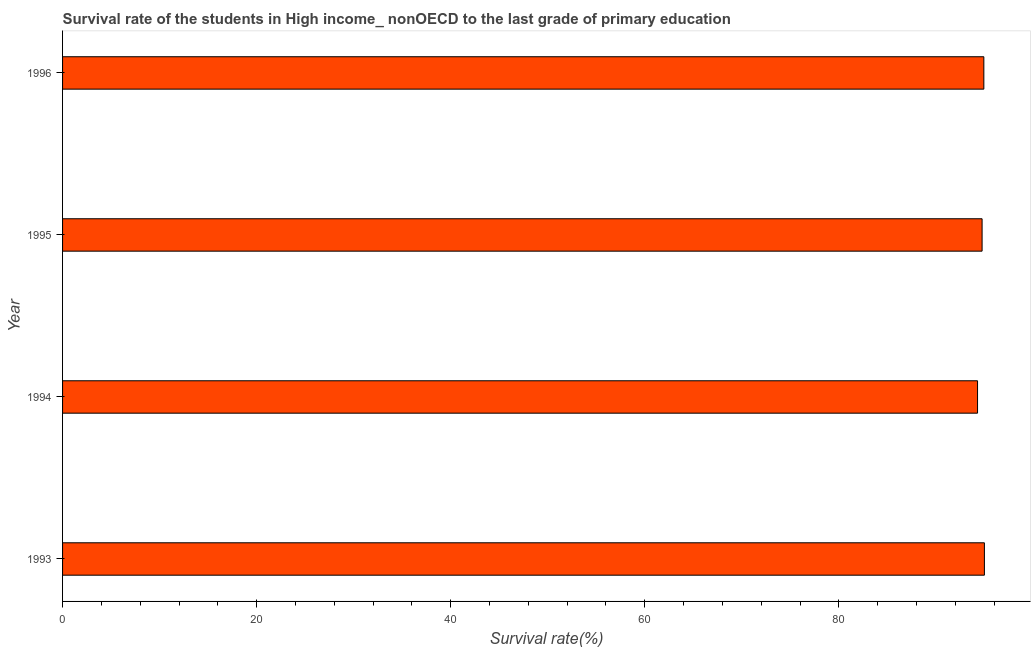Does the graph contain any zero values?
Provide a succinct answer. No. What is the title of the graph?
Provide a succinct answer. Survival rate of the students in High income_ nonOECD to the last grade of primary education. What is the label or title of the X-axis?
Give a very brief answer. Survival rate(%). What is the label or title of the Y-axis?
Offer a terse response. Year. What is the survival rate in primary education in 1995?
Offer a very short reply. 94.77. Across all years, what is the maximum survival rate in primary education?
Provide a succinct answer. 95. Across all years, what is the minimum survival rate in primary education?
Offer a terse response. 94.3. In which year was the survival rate in primary education maximum?
Provide a short and direct response. 1993. What is the sum of the survival rate in primary education?
Your answer should be compact. 379.01. What is the difference between the survival rate in primary education in 1993 and 1994?
Provide a short and direct response. 0.71. What is the average survival rate in primary education per year?
Offer a terse response. 94.75. What is the median survival rate in primary education?
Give a very brief answer. 94.86. Do a majority of the years between 1995 and 1994 (inclusive) have survival rate in primary education greater than 16 %?
Give a very brief answer. No. What is the ratio of the survival rate in primary education in 1994 to that in 1995?
Offer a terse response. 0.99. Is the difference between the survival rate in primary education in 1993 and 1996 greater than the difference between any two years?
Your response must be concise. No. What is the difference between the highest and the second highest survival rate in primary education?
Offer a very short reply. 0.06. Is the sum of the survival rate in primary education in 1994 and 1996 greater than the maximum survival rate in primary education across all years?
Offer a terse response. Yes. What is the difference between the highest and the lowest survival rate in primary education?
Your answer should be very brief. 0.71. In how many years, is the survival rate in primary education greater than the average survival rate in primary education taken over all years?
Keep it short and to the point. 3. How many years are there in the graph?
Give a very brief answer. 4. Are the values on the major ticks of X-axis written in scientific E-notation?
Offer a terse response. No. What is the Survival rate(%) of 1993?
Your answer should be compact. 95. What is the Survival rate(%) in 1994?
Provide a succinct answer. 94.3. What is the Survival rate(%) of 1995?
Make the answer very short. 94.77. What is the Survival rate(%) of 1996?
Offer a very short reply. 94.95. What is the difference between the Survival rate(%) in 1993 and 1994?
Your answer should be compact. 0.71. What is the difference between the Survival rate(%) in 1993 and 1995?
Your response must be concise. 0.24. What is the difference between the Survival rate(%) in 1993 and 1996?
Provide a short and direct response. 0.06. What is the difference between the Survival rate(%) in 1994 and 1995?
Your answer should be very brief. -0.47. What is the difference between the Survival rate(%) in 1994 and 1996?
Ensure brevity in your answer.  -0.65. What is the difference between the Survival rate(%) in 1995 and 1996?
Provide a short and direct response. -0.18. What is the ratio of the Survival rate(%) in 1993 to that in 1995?
Provide a short and direct response. 1. What is the ratio of the Survival rate(%) in 1994 to that in 1995?
Keep it short and to the point. 0.99. What is the ratio of the Survival rate(%) in 1994 to that in 1996?
Keep it short and to the point. 0.99. What is the ratio of the Survival rate(%) in 1995 to that in 1996?
Offer a very short reply. 1. 